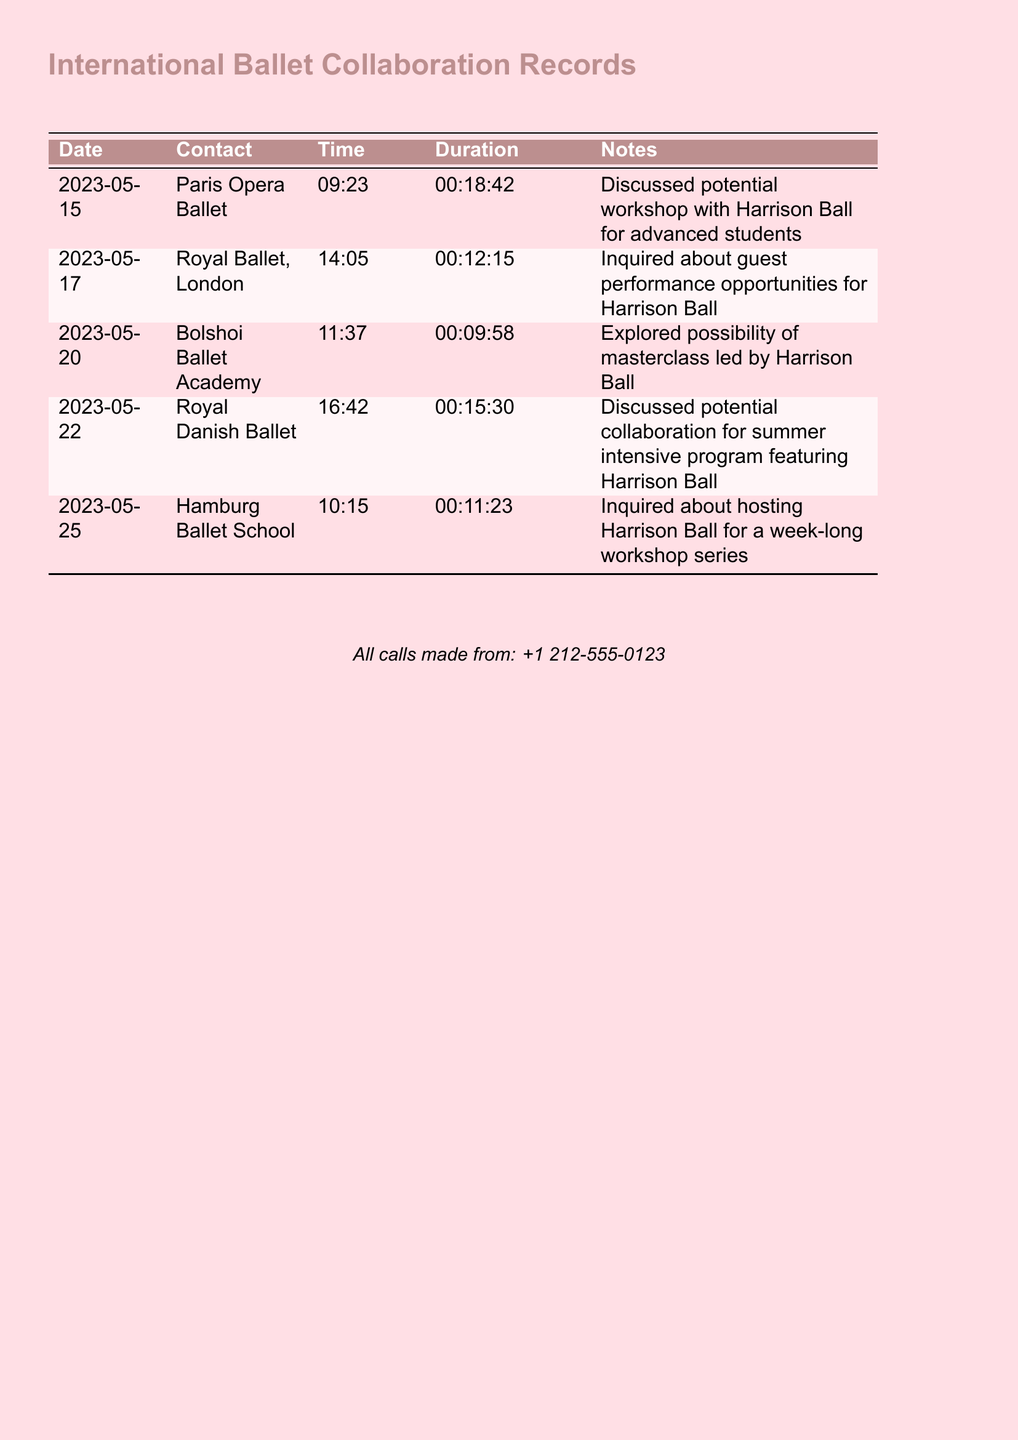What is the date of the call with the Paris Opera Ballet? The date listed for the call with the Paris Opera Ballet is specifically noted in the document.
Answer: 2023-05-15 What was discussed during the call with the Royal Ballet, London? The notes for the call clearly outline the subject of discussion with the Royal Ballet, London.
Answer: Guest performance opportunities for Harrison Ball What is the duration of the call with Hamburg Ballet School? The duration of the call is explicitly stated in the records.
Answer: 00:11:23 Which ballet school was contacted on May 22, 2023? The document specifies the ballet school contacted on this date.
Answer: Royal Danish Ballet How many calls were made regarding workshops featuring Harrison Ball? Count the relevant notes in the document related to workshops for Harrison Ball.
Answer: 3 What time was the call with Bolshoi Ballet Academy? The specific time of the call is recorded in the document.
Answer: 11:37 For which program was a collaboration discussed with the Royal Danish Ballet? The key detail of the collaboration is included in the notes of that call.
Answer: Summer intensive program What was the main focus of the call with Paris Opera Ballet? The document provides a clear summary of the call's content in the notes.
Answer: Potential workshop with Harrison Ball for advanced students How many different companies or schools were contacted? The total number of entries in the table indicates this.
Answer: 5 